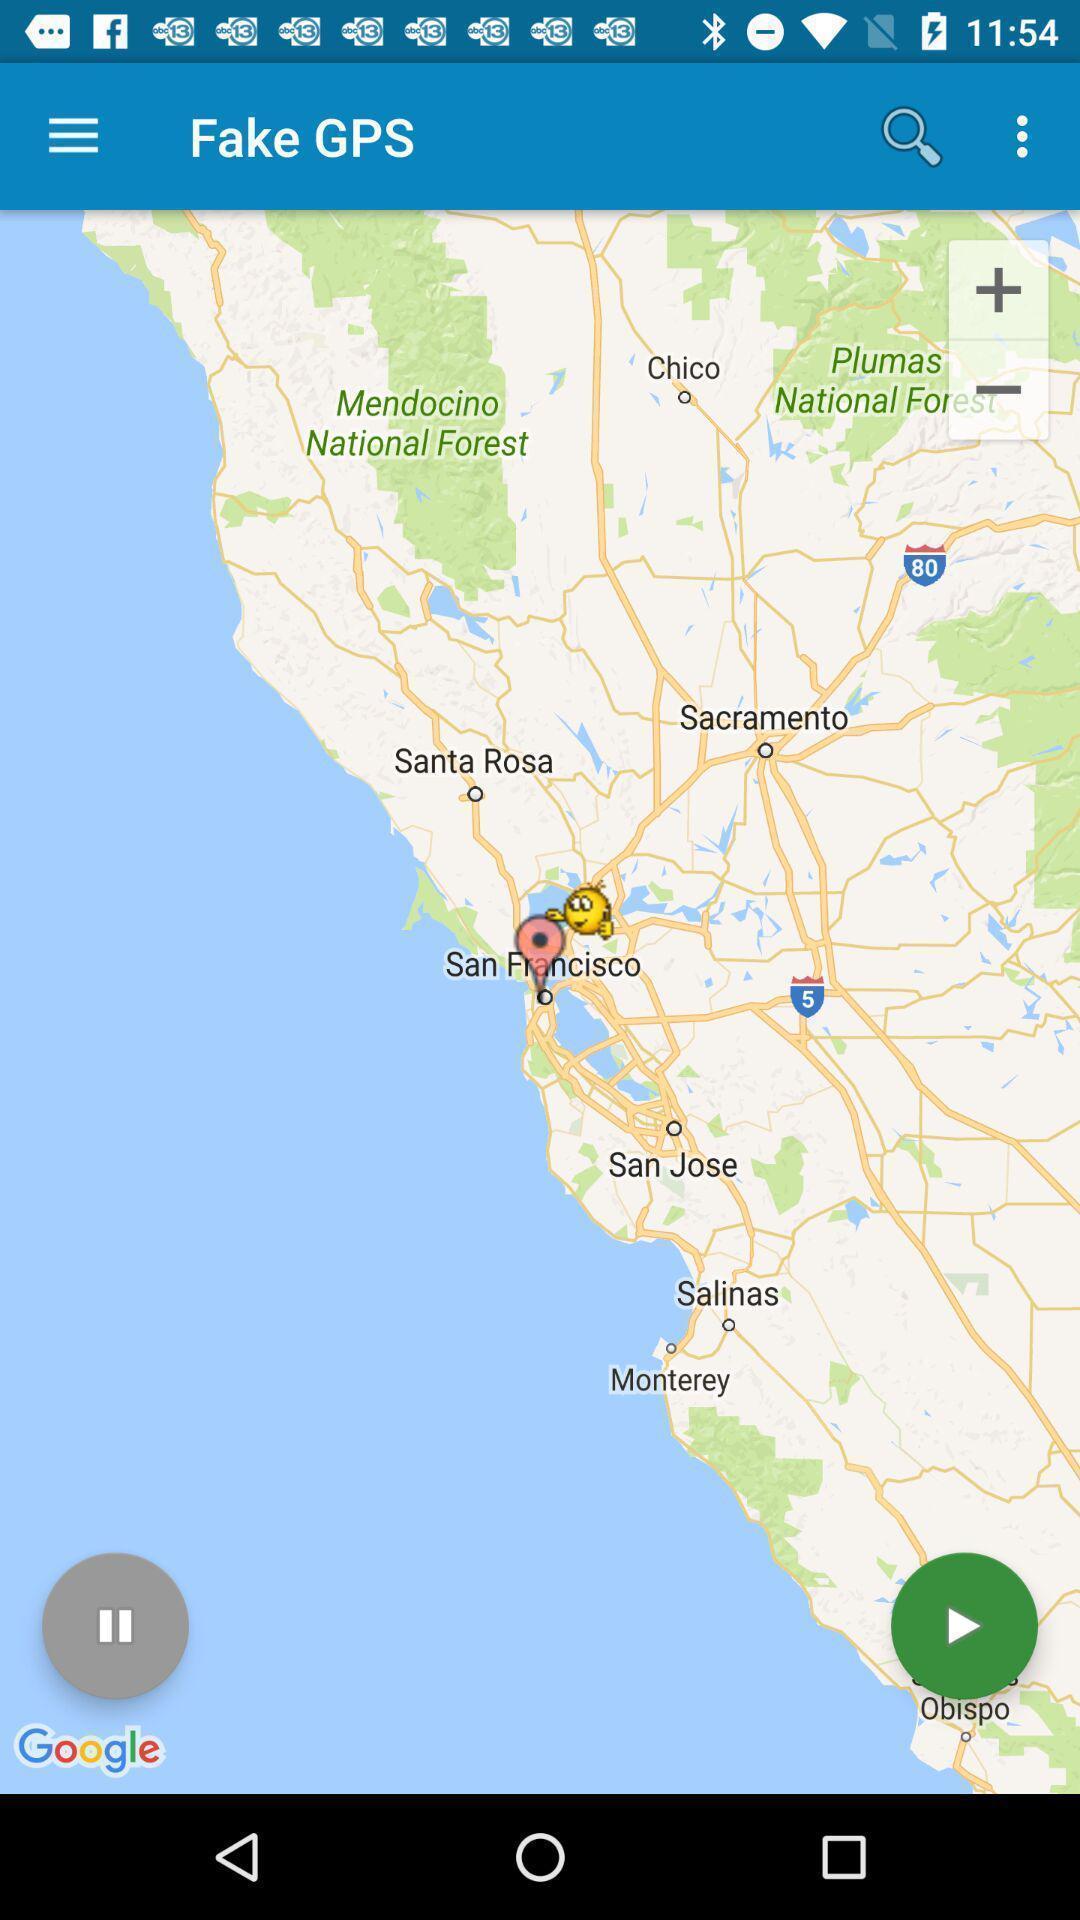Provide a detailed account of this screenshot. Screen showing a fake navigation page. 